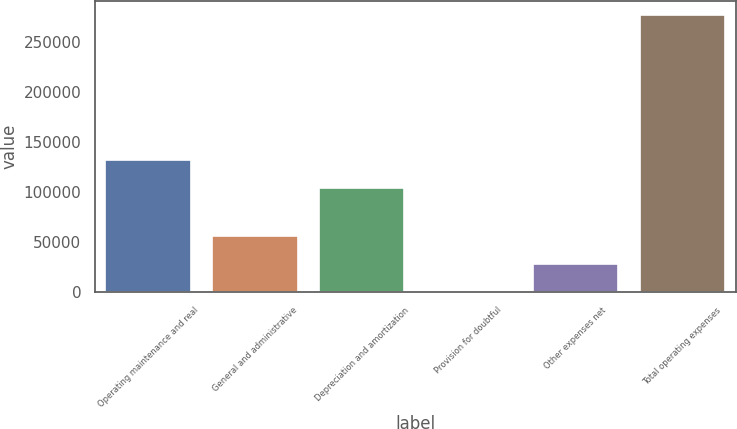Convert chart to OTSL. <chart><loc_0><loc_0><loc_500><loc_500><bar_chart><fcel>Operating maintenance and real<fcel>General and administrative<fcel>Depreciation and amortization<fcel>Provision for doubtful<fcel>Other expenses net<fcel>Total operating expenses<nl><fcel>132223<fcel>56478<fcel>104569<fcel>1170<fcel>28824<fcel>277710<nl></chart> 